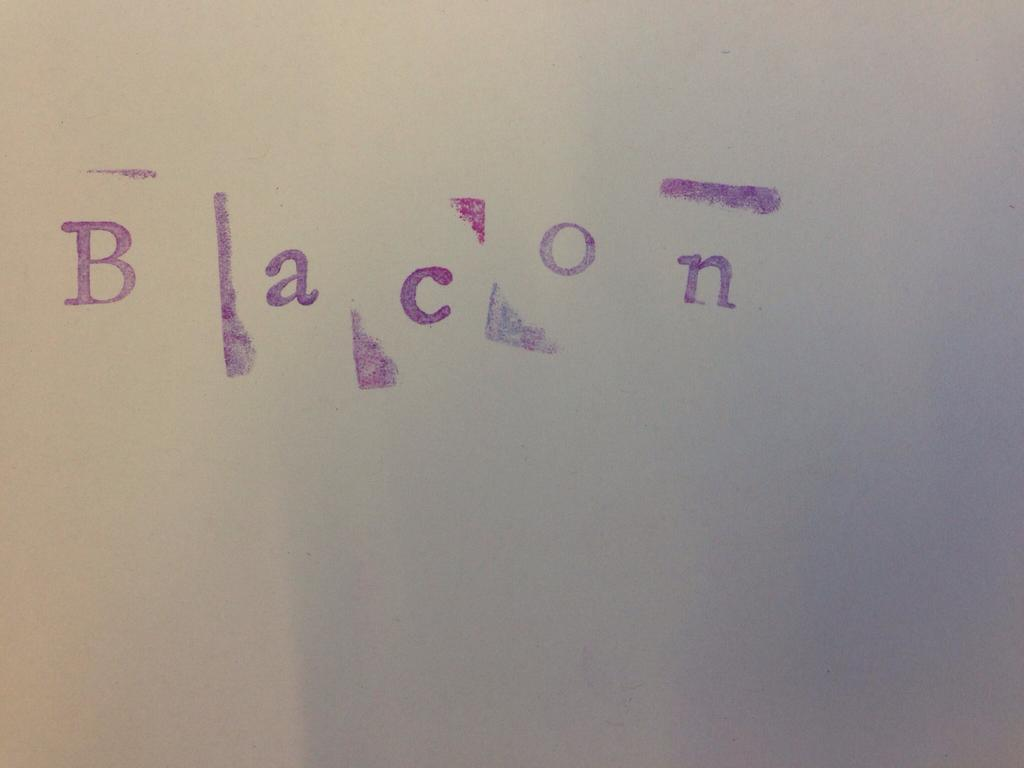<image>
Summarize the visual content of the image. The word "BACON" is stamped in purple on a white board. 